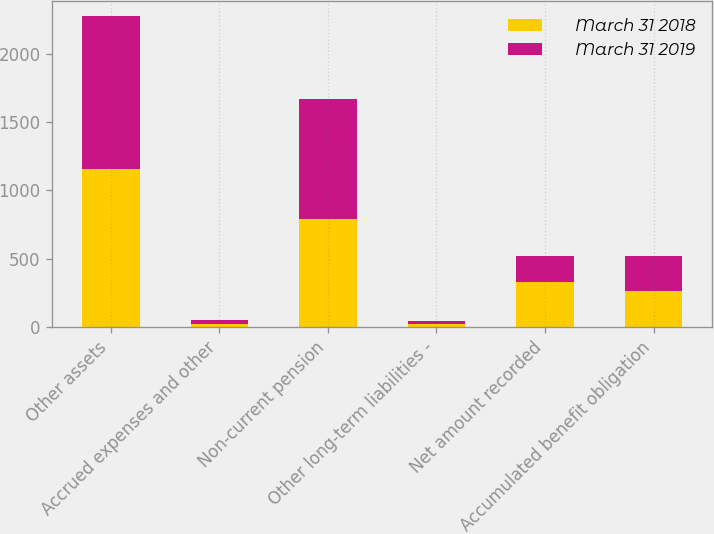Convert chart to OTSL. <chart><loc_0><loc_0><loc_500><loc_500><stacked_bar_chart><ecel><fcel>Other assets<fcel>Accrued expenses and other<fcel>Non-current pension<fcel>Other long-term liabilities -<fcel>Net amount recorded<fcel>Accumulated benefit obligation<nl><fcel>March 31 2018<fcel>1157<fcel>20<fcel>790<fcel>20<fcel>327<fcel>258.5<nl><fcel>March 31 2019<fcel>1118<fcel>28<fcel>879<fcel>21<fcel>190<fcel>258.5<nl></chart> 